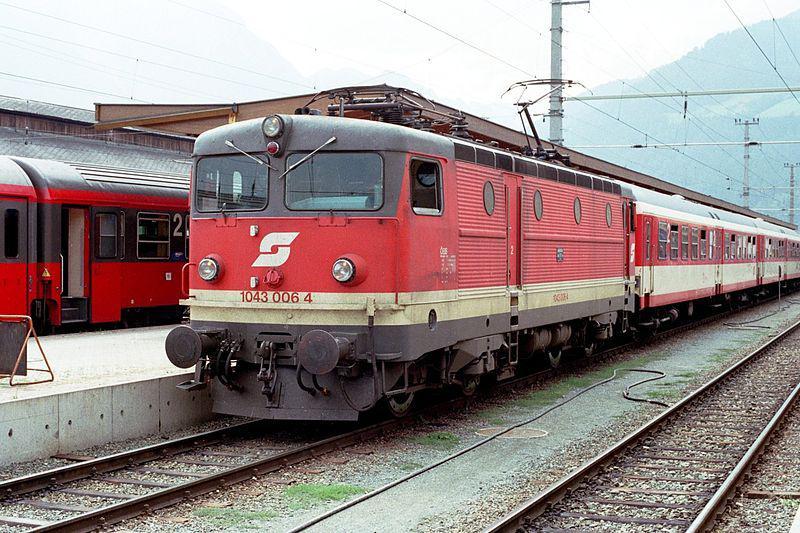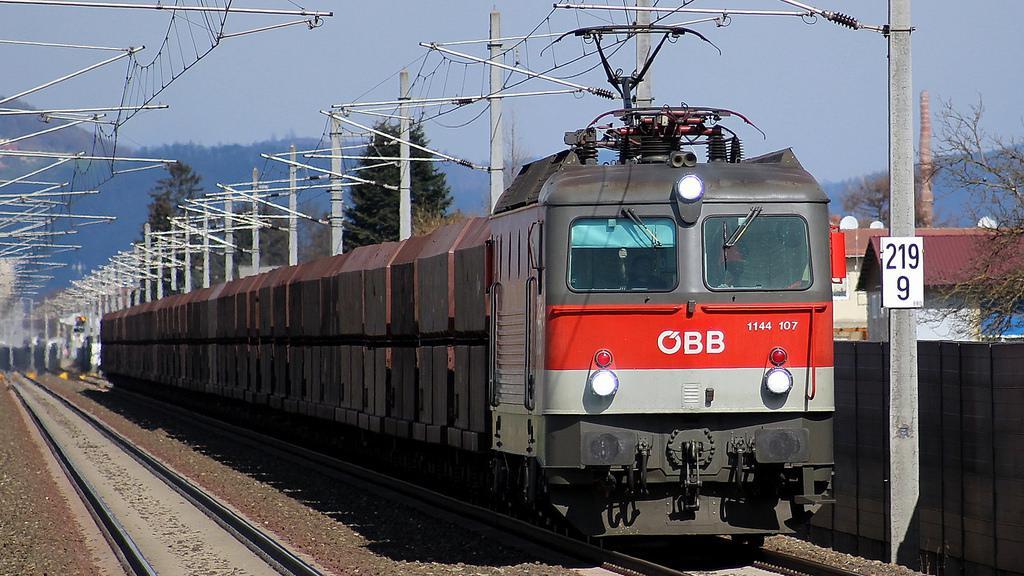The first image is the image on the left, the second image is the image on the right. Considering the images on both sides, is "Both trains are pointed in the same direction." valid? Answer yes or no. No. The first image is the image on the left, the second image is the image on the right. Given the left and right images, does the statement "One image shows a leftward headed train, and the other shows a rightward angled train." hold true? Answer yes or no. Yes. 